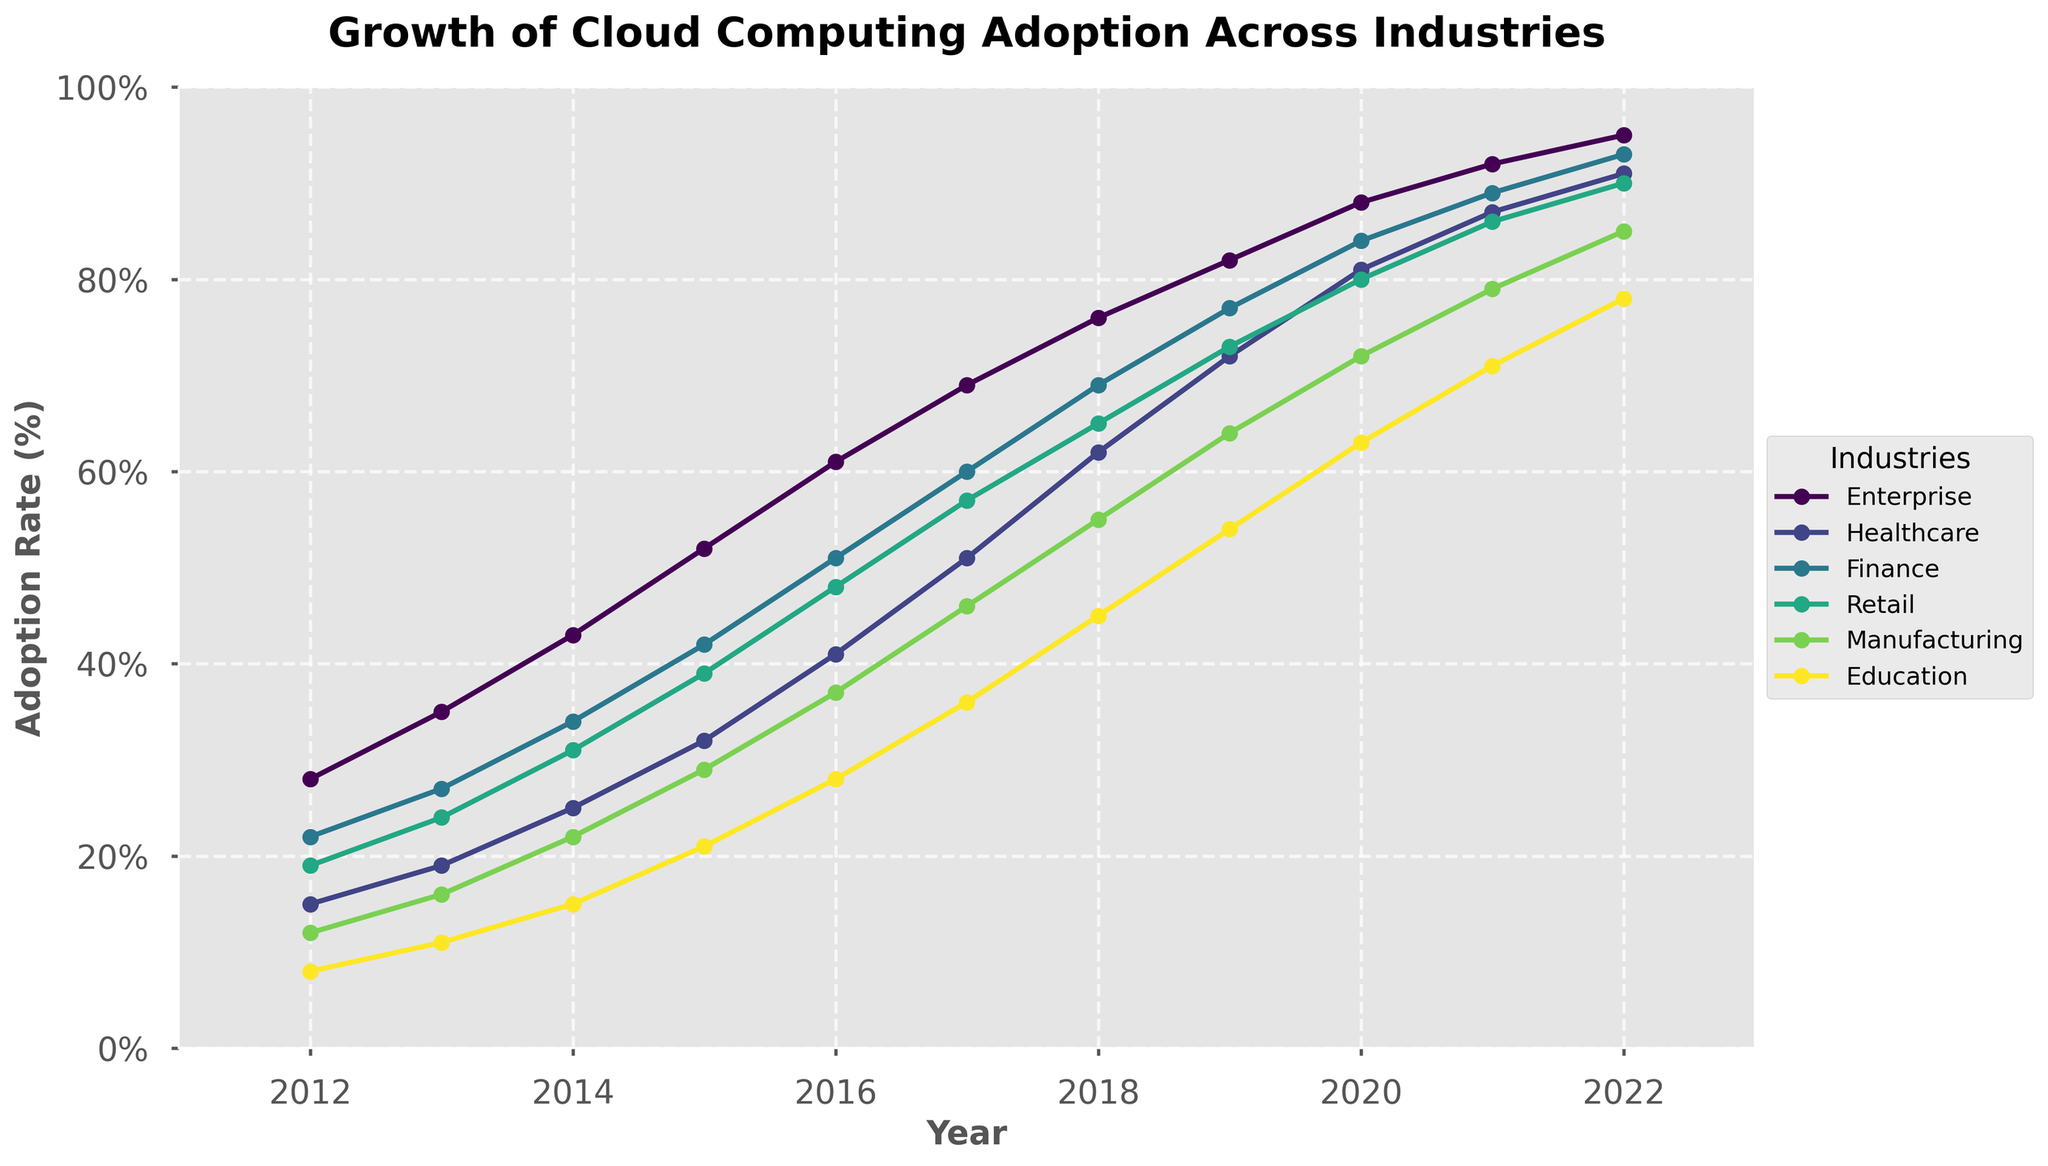Which industry had the highest cloud computing adoption in 2022? To determine this, look at the endpoints of the lines on the right side of the plot. The "Enterprise" industry reaches the topmost point among all.
Answer: Enterprise How did the adoption rate in the healthcare industry change from 2015 to 2019? Find the values for healthcare in 2015 (32) and 2019 (72). Subtract the 2015 value from the 2019 value: 72 - 32 = 40.
Answer: Increased by 40% Which two industries had nearly similar adoption rates in 2018? Compare the end-points for all lines in 2018. Both Healthcare and Education are close to 62 and 45 respectively, indicating similarity with a smaller gap than other industry comparisons.
Answer: Healthcare and Education In which year did the retail industry surpass the 50% adoption rate? Follow the retail line until it crosses the 50% mark. This occurs between 2015 (39) and 2016 (48).
Answer: 2016 What's the average growth rate per year for the finance industry from 2012 to 2022? Find the difference in adoption rate for finance between 2022 (93) and 2012 (22), then divide this by the number of years (2022-2012=10). (93 - 22) / 10 = 7.1% per year
Answer: 7.1% Which industry had the most significant increase in adoption from 2016 to 2017? Calculate the differences for each industry between 2016 and 2017 and identify the largest one. Enterprise: 69-61=8, Healthcare: 51-41=10, Finance: 60-51=9, Retail: 57-48=9, Manufacturing: 46-37=9, Education: 36-28=8. Healthcare has the largest increase of 10.
Answer: Healthcare What's the difference in cloud computing adoption rates between manufacturing and retail in 2020? Look up the 2020 values for manufacturing (72) and retail (80), then subtract the smaller from the larger: 80 - 72 = 8.
Answer: 8% By how much did education's adoption rate grow from 2014 to 2021? Find the values for education in 2014 (15) and 2021 (71), then subtract 2014 from 2021: 71 - 15 = 56.
Answer: Increased by 56% Which industry had lower adoption rates than finance in 2016 but higher in 2020? Compare the adoption rates for all industries with finance (51 in 2016, 84 in 2020) in the respective years. Retail (48 in 2016, 80 in 2020) and Healthcare (41 in 2016, 81 in 2020). So, Retail and Healthcare both meet the condition.
Answer: Retail and Healthcare What is the trend of enterprise adoption rates from 2012 to 2022? Observe the enterprise line from 2012 (28) to 2022 (95), which shows a consistent increase.
Answer: Consistently Increasing 